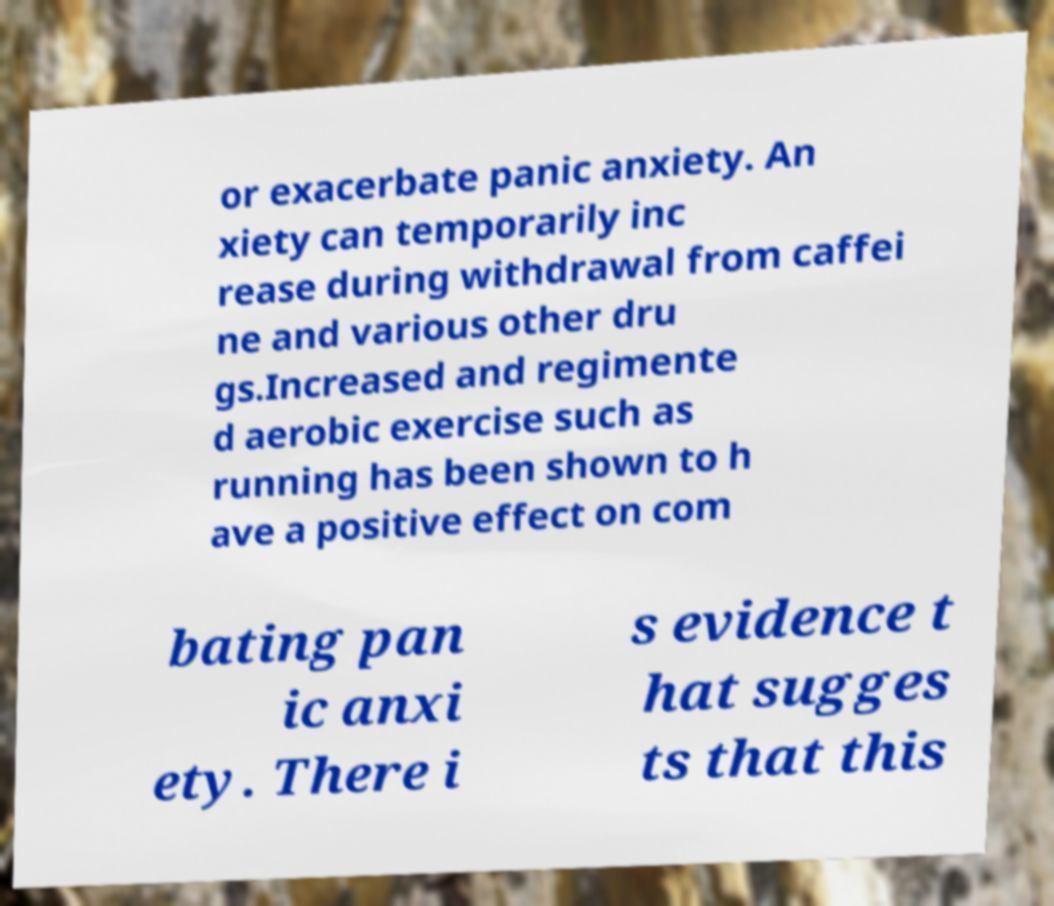For documentation purposes, I need the text within this image transcribed. Could you provide that? or exacerbate panic anxiety. An xiety can temporarily inc rease during withdrawal from caffei ne and various other dru gs.Increased and regimente d aerobic exercise such as running has been shown to h ave a positive effect on com bating pan ic anxi ety. There i s evidence t hat sugges ts that this 